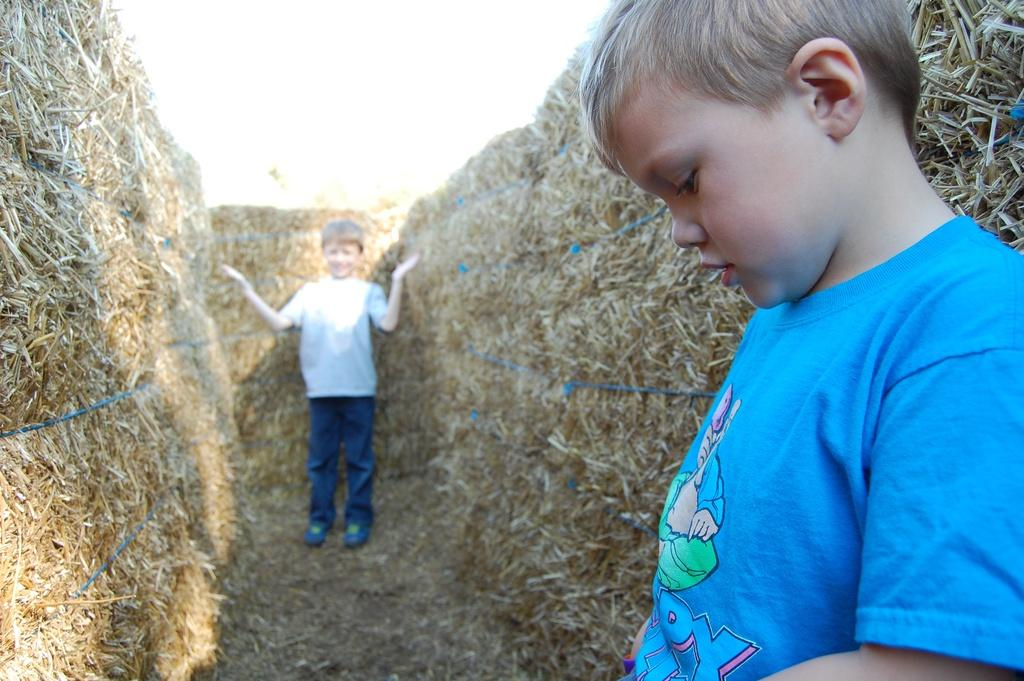How many children are present in the image? There are two children in the image. What are the children standing beside? The children are standing beside bundles of dried grass. How are the bundles of dried grass secured? The bundles of dried grass are tied with a rope. What type of cushion can be seen on the side of the leg in the image? There is no cushion or leg present in the image; it features two children standing beside bundles of dried grass tied with a rope. 